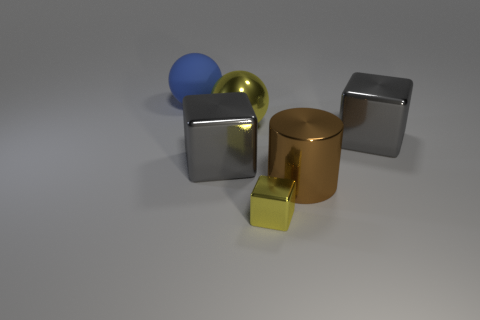What do the objects in the image tell you about the possible purpose of this scene? Given the simplicity and the arrangement of geometric shapes, this scene likely serves an illustrative or educational purpose, possibly for demonstrating properties of light, material, and shadow in a controlled setting. 